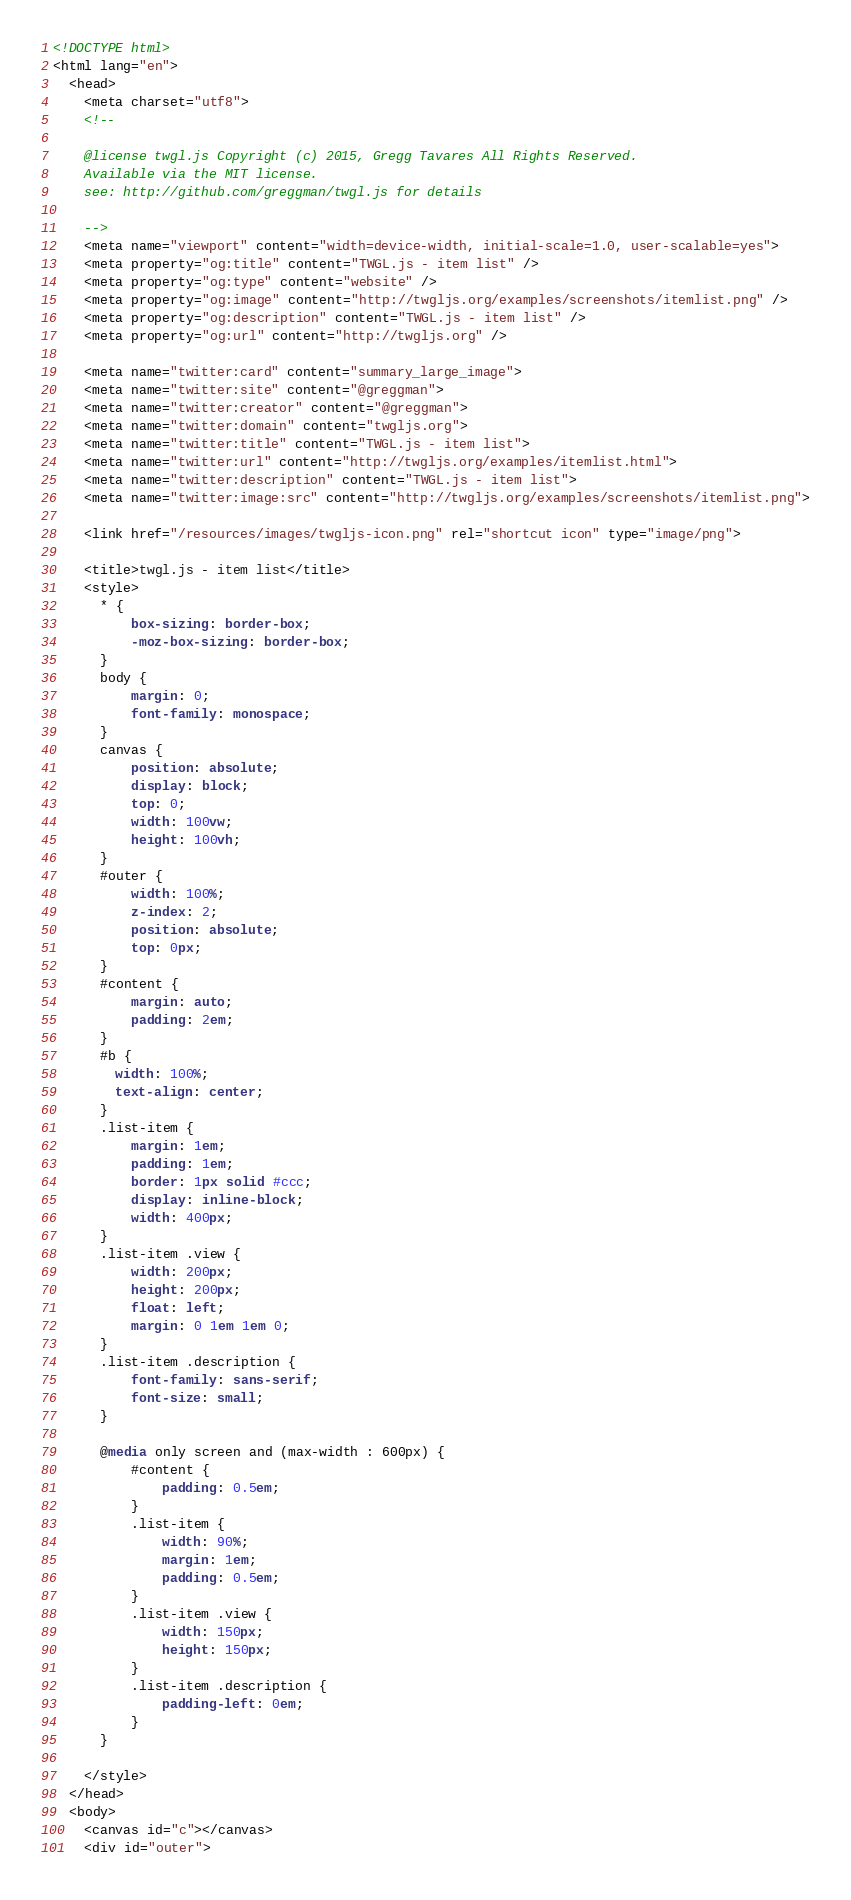<code> <loc_0><loc_0><loc_500><loc_500><_HTML_><!DOCTYPE html>
<html lang="en">
  <head>
    <meta charset="utf8">
    <!--

    @license twgl.js Copyright (c) 2015, Gregg Tavares All Rights Reserved.
    Available via the MIT license.
    see: http://github.com/greggman/twgl.js for details

    -->
    <meta name="viewport" content="width=device-width, initial-scale=1.0, user-scalable=yes">
    <meta property="og:title" content="TWGL.js - item list" />
    <meta property="og:type" content="website" />
    <meta property="og:image" content="http://twgljs.org/examples/screenshots/itemlist.png" />
    <meta property="og:description" content="TWGL.js - item list" />
    <meta property="og:url" content="http://twgljs.org" />

    <meta name="twitter:card" content="summary_large_image">
    <meta name="twitter:site" content="@greggman">
    <meta name="twitter:creator" content="@greggman">
    <meta name="twitter:domain" content="twgljs.org">
    <meta name="twitter:title" content="TWGL.js - item list">
    <meta name="twitter:url" content="http://twgljs.org/examples/itemlist.html">
    <meta name="twitter:description" content="TWGL.js - item list">
    <meta name="twitter:image:src" content="http://twgljs.org/examples/screenshots/itemlist.png">

    <link href="/resources/images/twgljs-icon.png" rel="shortcut icon" type="image/png">

    <title>twgl.js - item list</title>
    <style>
      * {
          box-sizing: border-box;
          -moz-box-sizing: border-box;
      }
      body {
          margin: 0;
          font-family: monospace;
      }
      canvas {
          position: absolute;
          display: block;
          top: 0;
          width: 100vw;
          height: 100vh;
      }
      #outer {
          width: 100%;
          z-index: 2;
          position: absolute;
          top: 0px;
      }
      #content {
          margin: auto;
          padding: 2em;
      }
      #b {
        width: 100%;
        text-align: center;
      }
      .list-item {
          margin: 1em;
          padding: 1em;
          border: 1px solid #ccc;
          display: inline-block;
          width: 400px;
      }
      .list-item .view {
          width: 200px;
          height: 200px;
          float: left;
          margin: 0 1em 1em 0;
      }
      .list-item .description {
          font-family: sans-serif;
          font-size: small;
      }

      @media only screen and (max-width : 600px) {
          #content {
              padding: 0.5em;
          }
          .list-item {
              width: 90%;
              margin: 1em;
              padding: 0.5em;
          }
          .list-item .view {
              width: 150px;
              height: 150px;
          }
          .list-item .description {
              padding-left: 0em;
          }
      }

    </style>
  </head>
  <body>
    <canvas id="c"></canvas>
    <div id="outer"></code> 